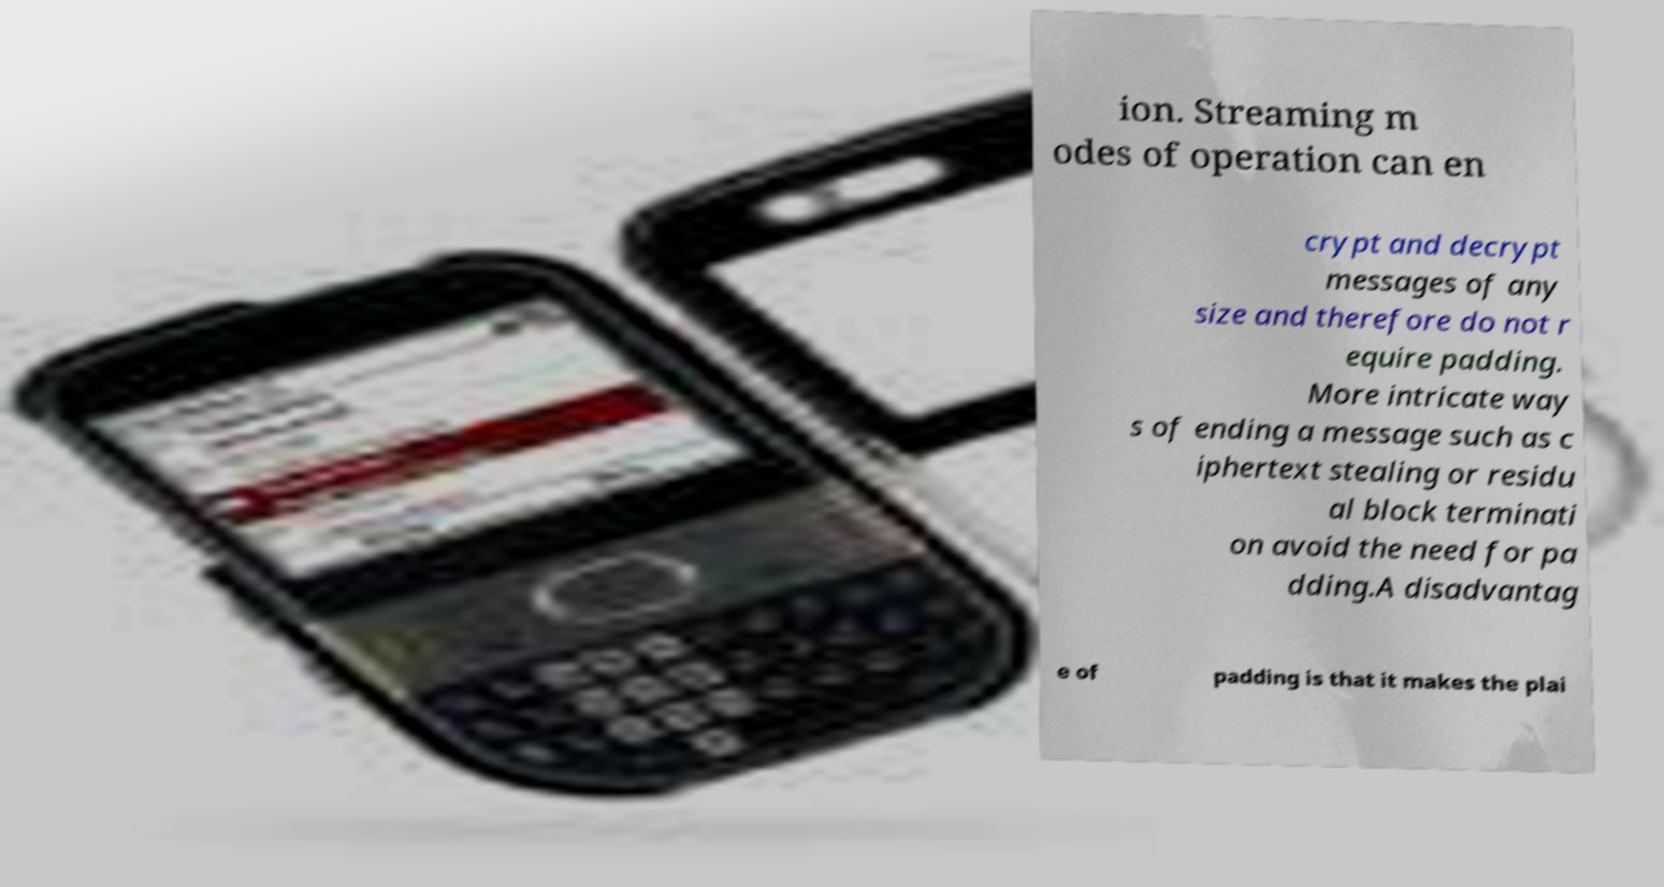I need the written content from this picture converted into text. Can you do that? ion. Streaming m odes of operation can en crypt and decrypt messages of any size and therefore do not r equire padding. More intricate way s of ending a message such as c iphertext stealing or residu al block terminati on avoid the need for pa dding.A disadvantag e of padding is that it makes the plai 